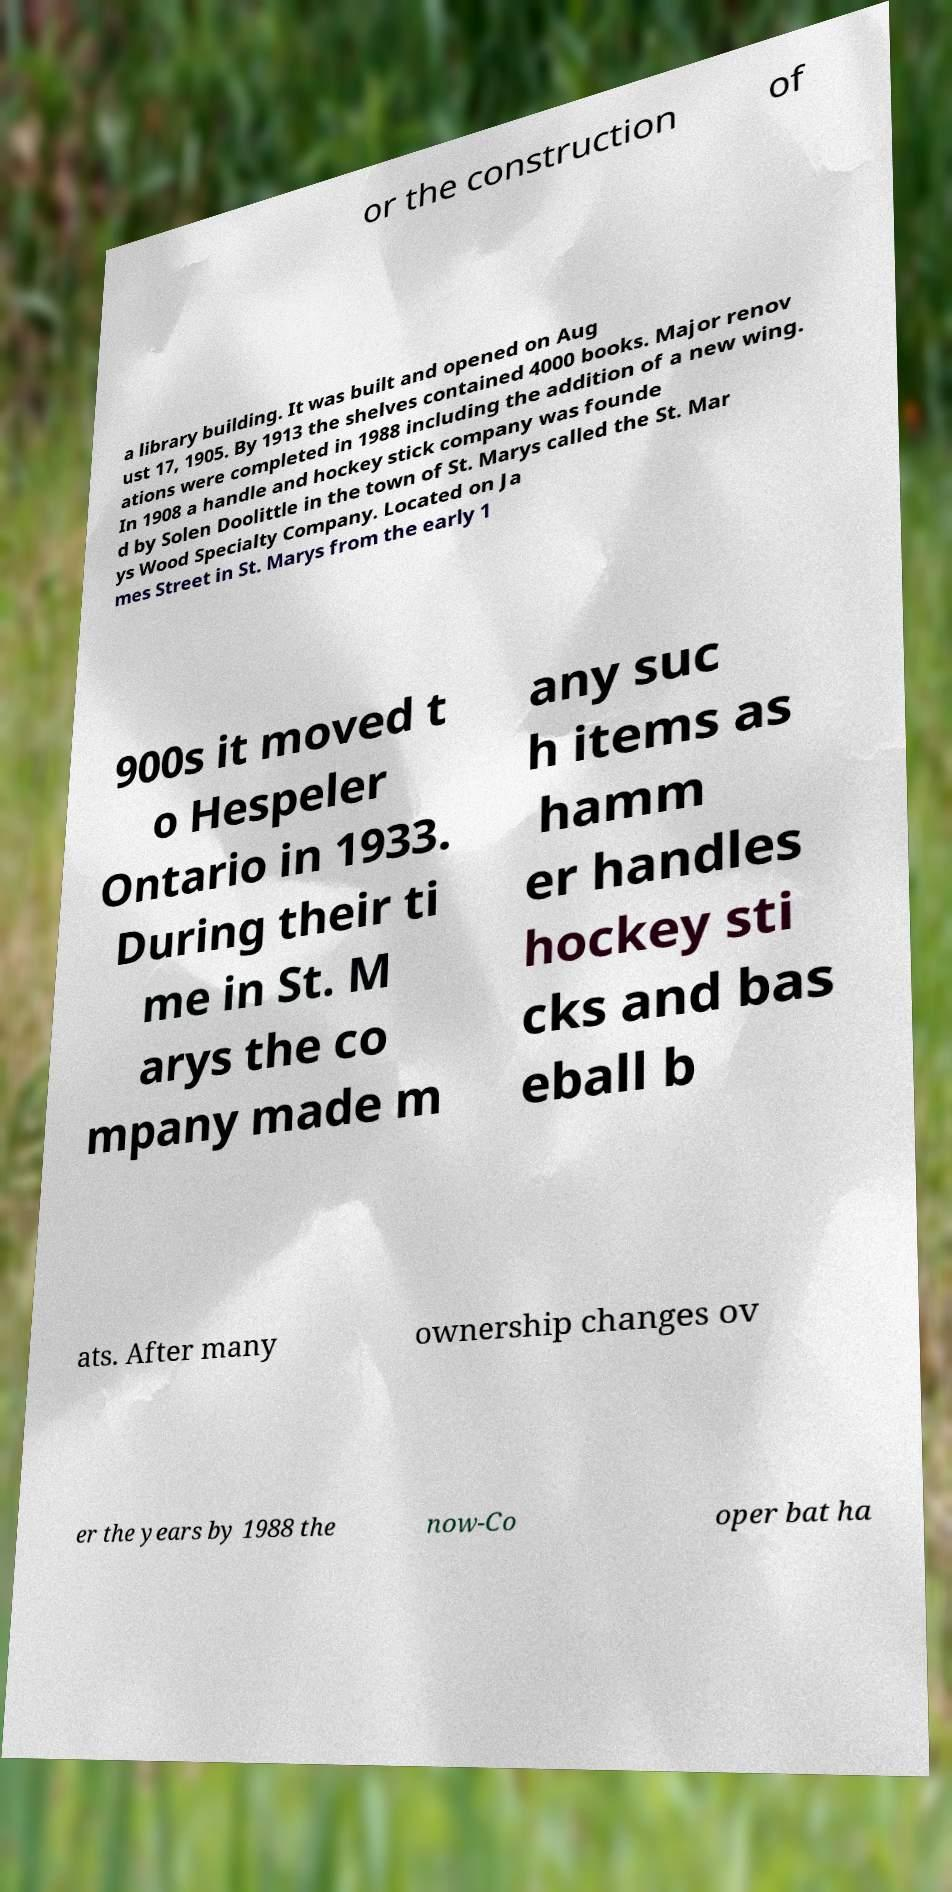Can you read and provide the text displayed in the image?This photo seems to have some interesting text. Can you extract and type it out for me? or the construction of a library building. It was built and opened on Aug ust 17, 1905. By 1913 the shelves contained 4000 books. Major renov ations were completed in 1988 including the addition of a new wing. In 1908 a handle and hockey stick company was founde d by Solen Doolittle in the town of St. Marys called the St. Mar ys Wood Specialty Company. Located on Ja mes Street in St. Marys from the early 1 900s it moved t o Hespeler Ontario in 1933. During their ti me in St. M arys the co mpany made m any suc h items as hamm er handles hockey sti cks and bas eball b ats. After many ownership changes ov er the years by 1988 the now-Co oper bat ha 